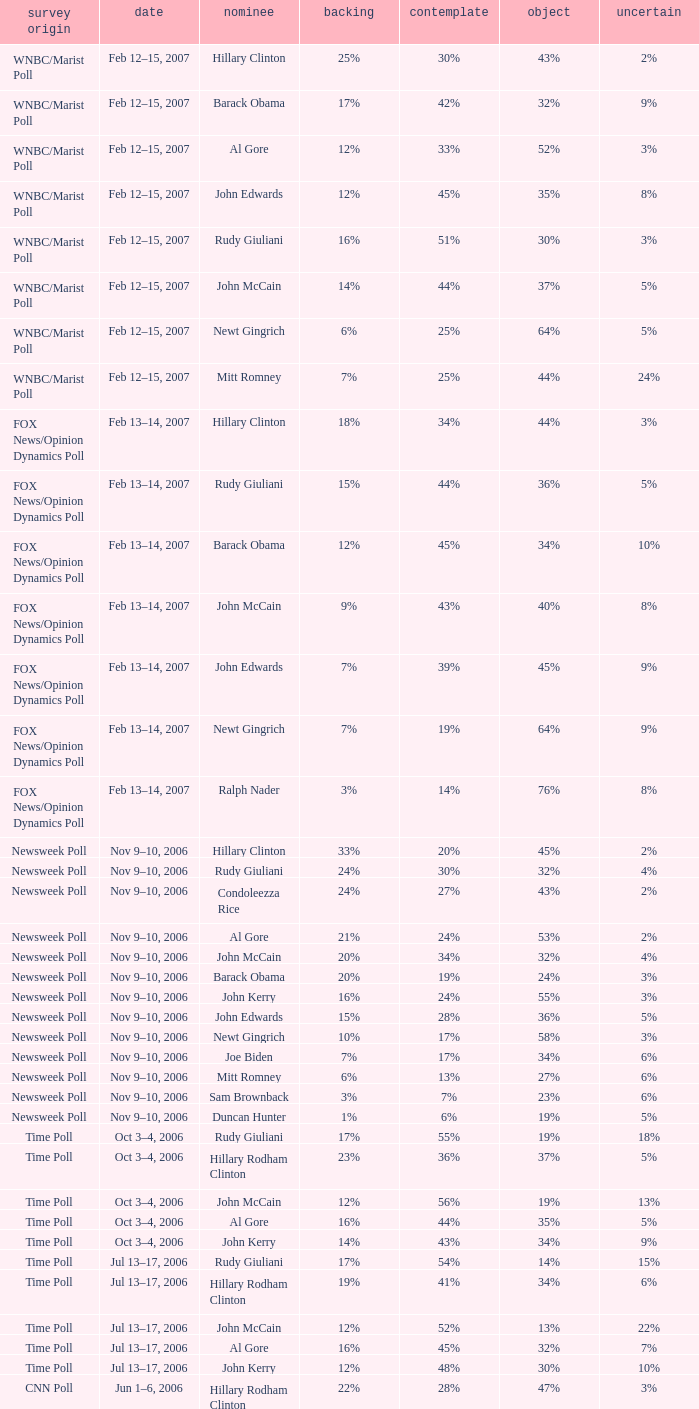What percentage of people said they would consider Rudy Giuliani as a candidate according to the Newsweek poll that showed 32% opposed him? 30%. 